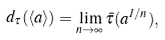<formula> <loc_0><loc_0><loc_500><loc_500>d _ { \tau } ( \langle a \rangle ) = \lim _ { n \to \infty } \bar { \tau } ( a ^ { 1 / n } ) ,</formula> 